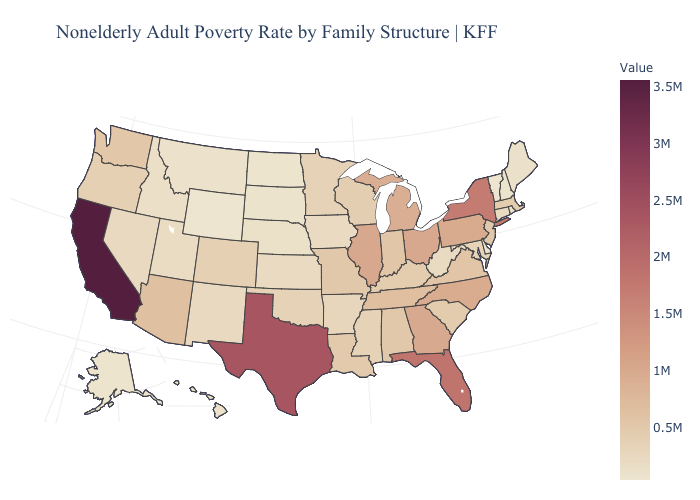Which states have the highest value in the USA?
Keep it brief. California. Among the states that border Florida , does Alabama have the lowest value?
Short answer required. Yes. Which states hav the highest value in the South?
Keep it brief. Texas. Is the legend a continuous bar?
Give a very brief answer. Yes. Among the states that border Arizona , which have the highest value?
Short answer required. California. Which states have the lowest value in the Northeast?
Be succinct. Vermont. 